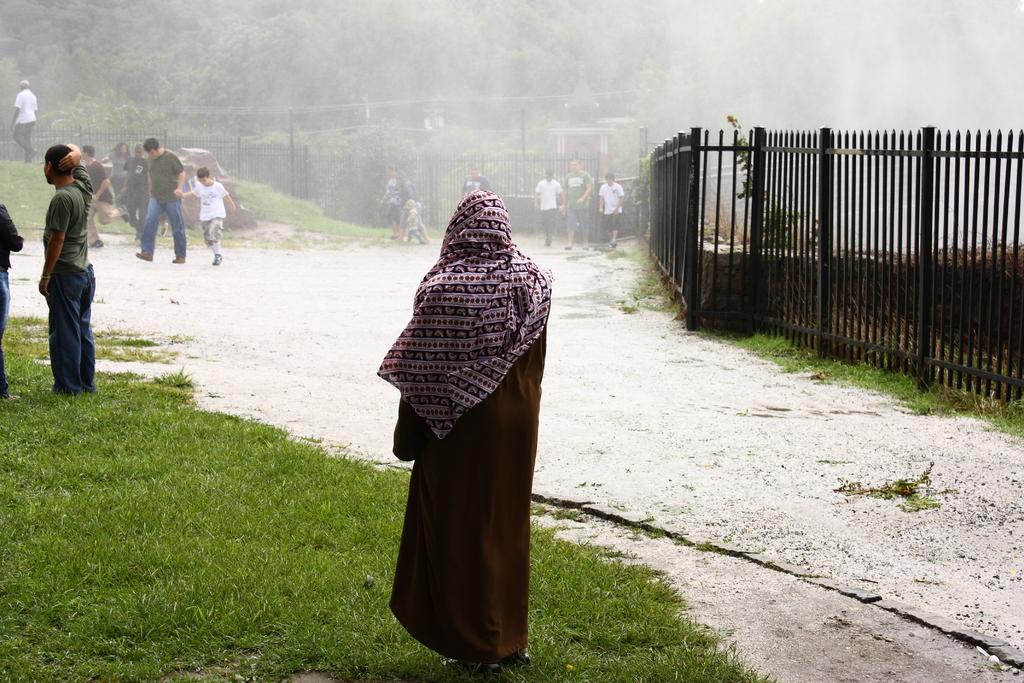In one or two sentences, can you explain what this image depicts? In this image few persons are standing on the grass land. Few persons are walking on the road. A person wearing a white shirt is walking on the grassland. There is a rock , behind there is a fence. Behind the fence there are few trees. 